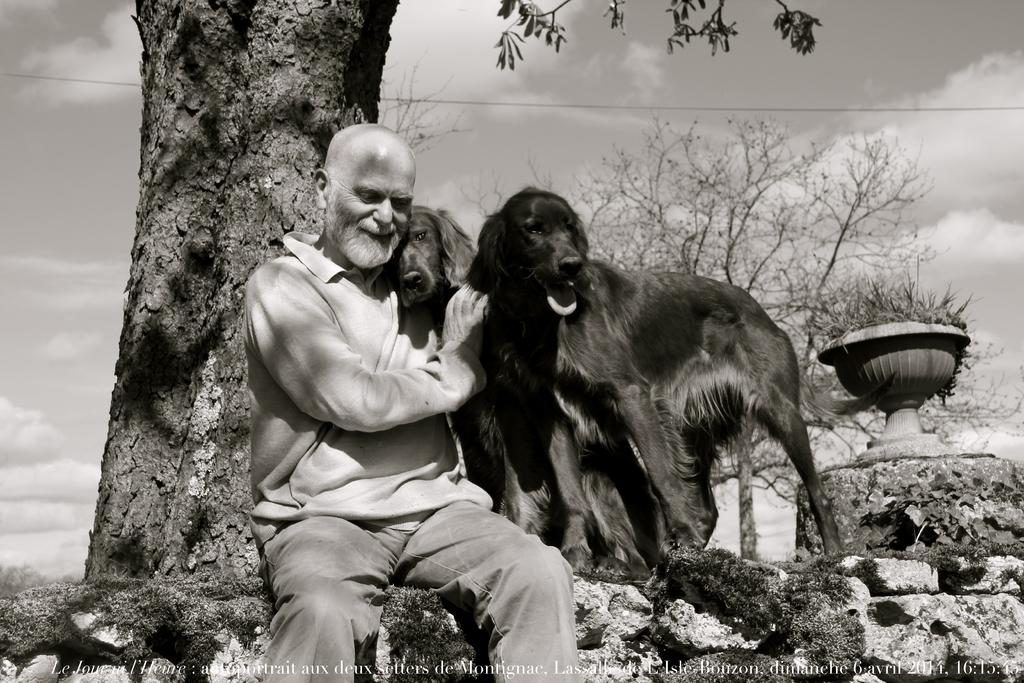What is the person in the image doing? The person is sitting in the image. Who or what is the person sitting with? The person is sitting with two dogs. What color are the dogs? The dogs are black. What is the facial expression of the person in the image? The person is smiling. What object can be seen in the image that is not related to the person or dogs? There is a rock in the image. What is visible in the background of the image? There is a pot and trees visible in the image. What part of the natural environment is visible in the image? The sky is visible in the image. How many chairs are visible in the image? There are no chairs visible in the image. What type of transportation is the person using in the image? The image does not show any form of transportation, as the person is sitting in a stationary position. 